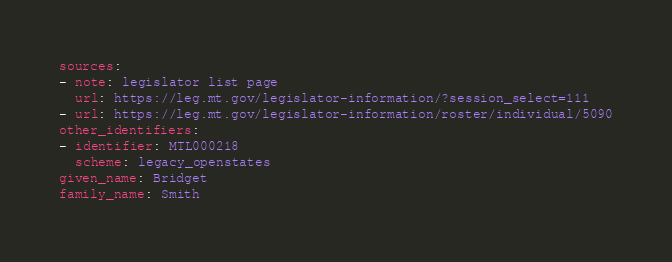Convert code to text. <code><loc_0><loc_0><loc_500><loc_500><_YAML_>sources:
- note: legislator list page
  url: https://leg.mt.gov/legislator-information/?session_select=111
- url: https://leg.mt.gov/legislator-information/roster/individual/5090
other_identifiers:
- identifier: MTL000218
  scheme: legacy_openstates
given_name: Bridget
family_name: Smith
</code> 